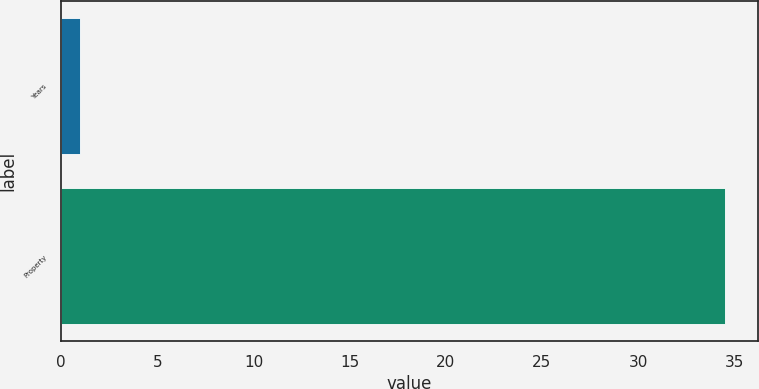Convert chart. <chart><loc_0><loc_0><loc_500><loc_500><bar_chart><fcel>Years<fcel>Property<nl><fcel>1<fcel>34.5<nl></chart> 